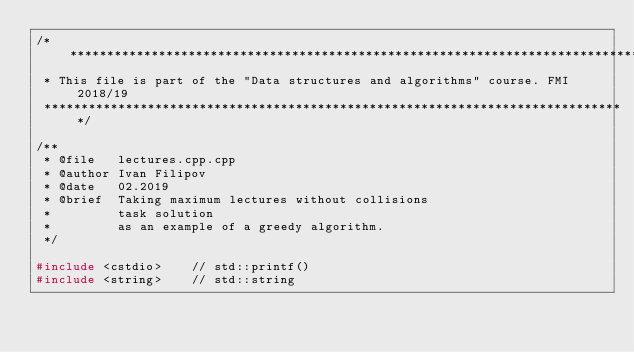<code> <loc_0><loc_0><loc_500><loc_500><_C++_>/*******************************************************************************
 * This file is part of the "Data structures and algorithms" course. FMI 2018/19 
 *******************************************************************************/

/**
 * @file   lectures.cpp.cpp
 * @author Ivan Filipov
 * @date   02.2019
 * @brief  Taking maximum lectures without collisions
 *         task solution
 *         as an example of a greedy algorithm.
 */

#include <cstdio>    // std::printf()
#include <string>    // std::string</code> 